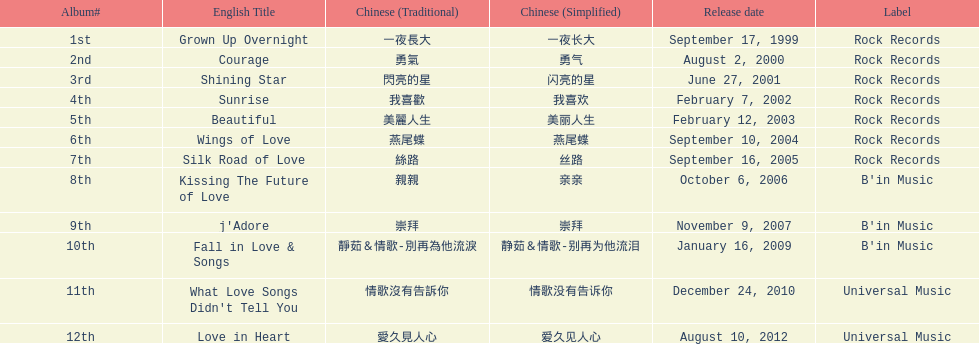Did the beautiful album come out before love in heart? Yes. Can you give me this table as a dict? {'header': ['Album#', 'English Title', 'Chinese (Traditional)', 'Chinese (Simplified)', 'Release date', 'Label'], 'rows': [['1st', 'Grown Up Overnight', '一夜長大', '一夜长大', 'September 17, 1999', 'Rock Records'], ['2nd', 'Courage', '勇氣', '勇气', 'August 2, 2000', 'Rock Records'], ['3rd', 'Shining Star', '閃亮的星', '闪亮的星', 'June 27, 2001', 'Rock Records'], ['4th', 'Sunrise', '我喜歡', '我喜欢', 'February 7, 2002', 'Rock Records'], ['5th', 'Beautiful', '美麗人生', '美丽人生', 'February 12, 2003', 'Rock Records'], ['6th', 'Wings of Love', '燕尾蝶', '燕尾蝶', 'September 10, 2004', 'Rock Records'], ['7th', 'Silk Road of Love', '絲路', '丝路', 'September 16, 2005', 'Rock Records'], ['8th', 'Kissing The Future of Love', '親親', '亲亲', 'October 6, 2006', "B'in Music"], ['9th', "j'Adore", '崇拜', '崇拜', 'November 9, 2007', "B'in Music"], ['10th', 'Fall in Love & Songs', '靜茹＆情歌-別再為他流淚', '静茹＆情歌-别再为他流泪', 'January 16, 2009', "B'in Music"], ['11th', "What Love Songs Didn't Tell You", '情歌沒有告訴你', '情歌没有告诉你', 'December 24, 2010', 'Universal Music'], ['12th', 'Love in Heart', '愛久見人心', '爱久见人心', 'August 10, 2012', 'Universal Music']]} 